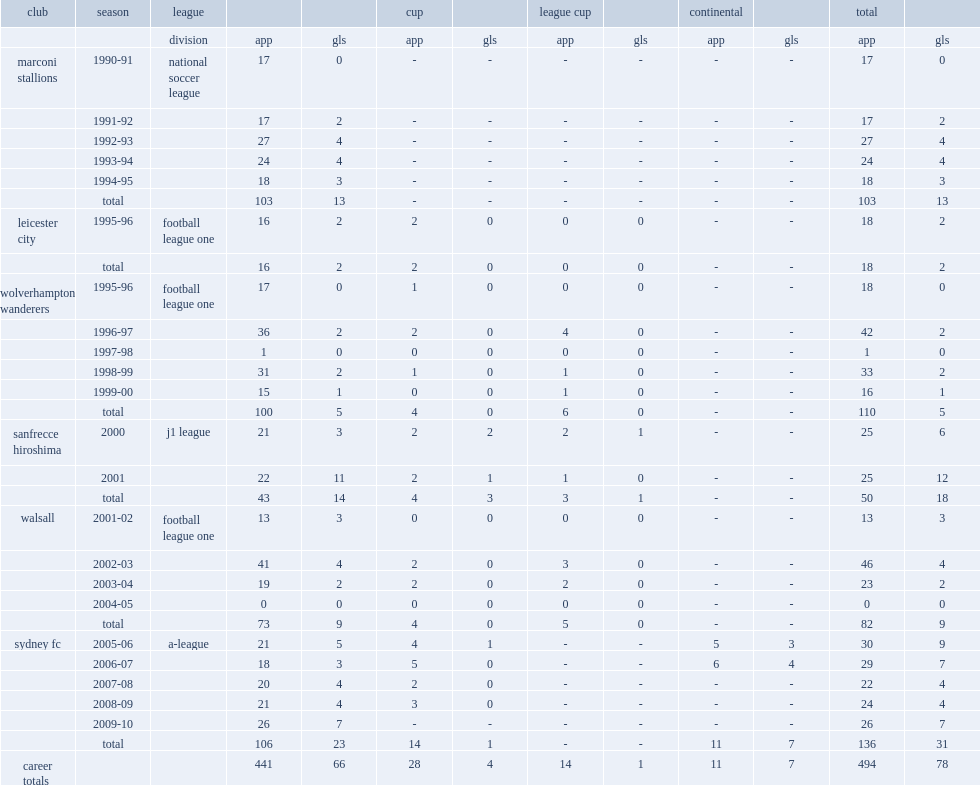Which club did corica play for in 2000? Sanfrecce hiroshima. 